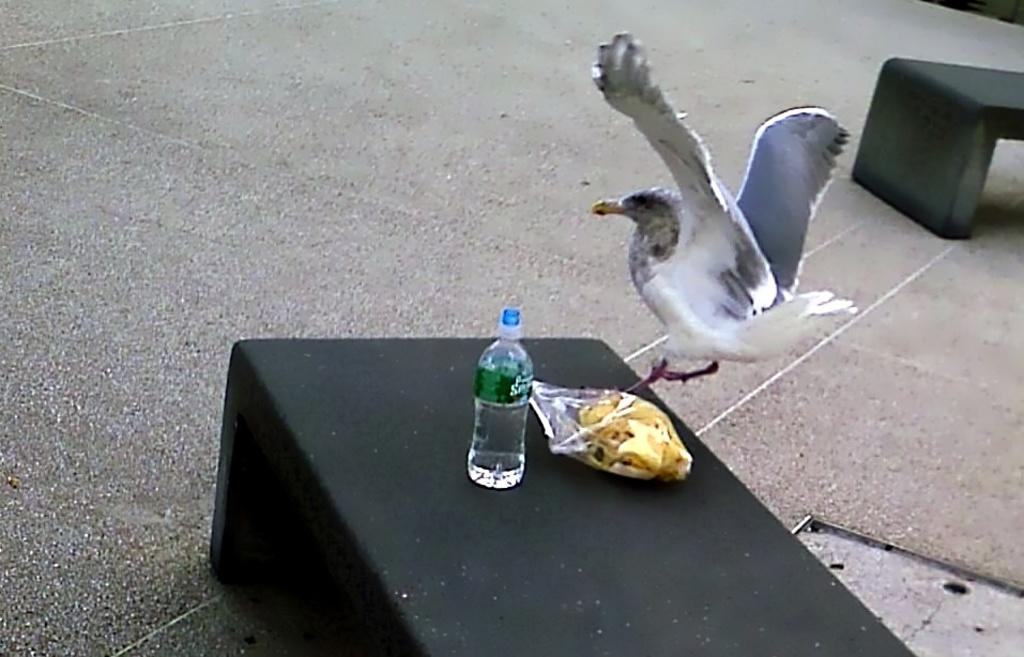What type of animal is in the image? There is a bird in the image. What else can be seen in the image besides the bird? There is a food packet and a bottle in the image. Where are these objects located? The objects are on a platform. What is the platform resting on? The platform is on the floor. What type of farmer is guiding the goose in the image? There is no farmer or goose present in the image. 